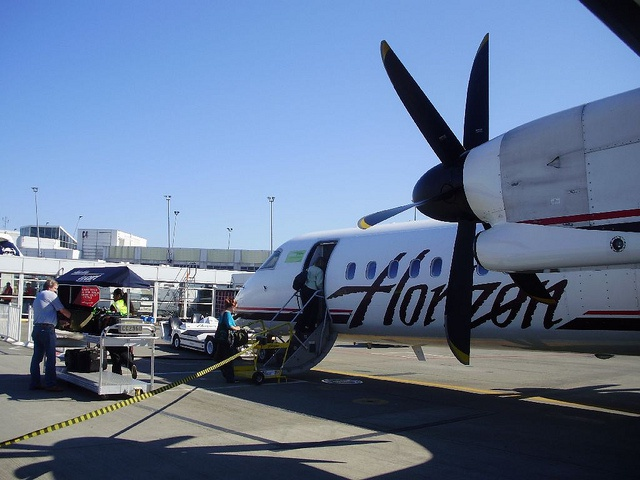Describe the objects in this image and their specific colors. I can see airplane in gray and black tones, people in gray, black, navy, and darkblue tones, people in gray, black, navy, and olive tones, car in gray, black, lightgray, and darkgray tones, and people in gray, black, blue, and navy tones in this image. 